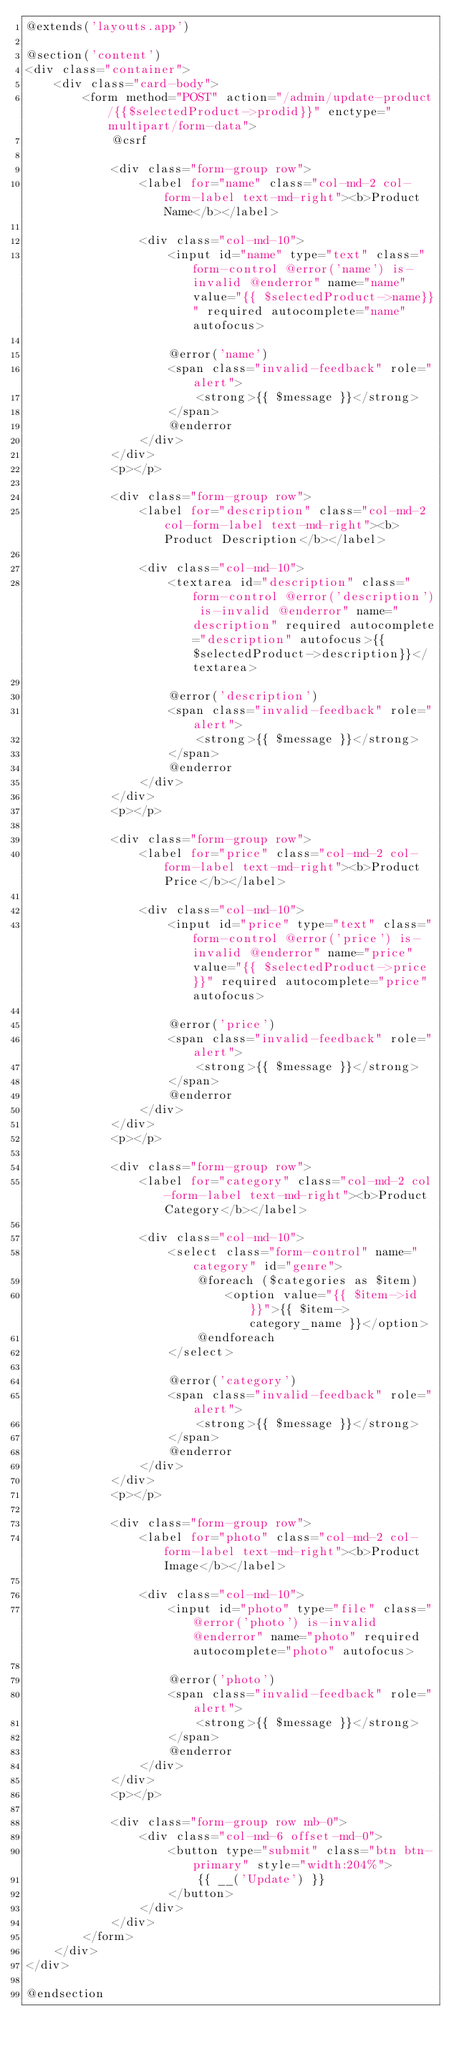Convert code to text. <code><loc_0><loc_0><loc_500><loc_500><_PHP_>@extends('layouts.app')

@section('content')
<div class="container">
    <div class="card-body">
        <form method="POST" action="/admin/update-product/{{$selectedProduct->prodid}}" enctype="multipart/form-data">
            @csrf

            <div class="form-group row">
                <label for="name" class="col-md-2 col-form-label text-md-right"><b>Product Name</b></label>

                <div class="col-md-10">
                    <input id="name" type="text" class="form-control @error('name') is-invalid @enderror" name="name" value="{{ $selectedProduct->name}}" required autocomplete="name" autofocus>

                    @error('name')
                    <span class="invalid-feedback" role="alert">
                        <strong>{{ $message }}</strong>
                    </span>
                    @enderror
                </div>
            </div>
            <p></p>

            <div class="form-group row">
                <label for="description" class="col-md-2 col-form-label text-md-right"><b>Product Description</b></label>

                <div class="col-md-10">
                    <textarea id="description" class="form-control @error('description') is-invalid @enderror" name="description" required autocomplete="description" autofocus>{{ $selectedProduct->description}}</textarea>

                    @error('description')
                    <span class="invalid-feedback" role="alert">
                        <strong>{{ $message }}</strong>
                    </span>
                    @enderror
                </div>
            </div>
            <p></p>

            <div class="form-group row">
                <label for="price" class="col-md-2 col-form-label text-md-right"><b>Product Price</b></label>

                <div class="col-md-10">
                    <input id="price" type="text" class="form-control @error('price') is-invalid @enderror" name="price" value="{{ $selectedProduct->price}}" required autocomplete="price" autofocus>

                    @error('price')
                    <span class="invalid-feedback" role="alert">
                        <strong>{{ $message }}</strong>
                    </span>
                    @enderror
                </div>
            </div>
            <p></p>

            <div class="form-group row">
                <label for="category" class="col-md-2 col-form-label text-md-right"><b>Product Category</b></label>

                <div class="col-md-10">
                    <select class="form-control" name="category" id="genre">
                        @foreach ($categories as $item)
                            <option value="{{ $item->id }}">{{ $item->category_name }}</option>
                        @endforeach
                    </select>

                    @error('category')
                    <span class="invalid-feedback" role="alert">
                        <strong>{{ $message }}</strong>
                    </span>
                    @enderror
                </div>
            </div>
            <p></p>

            <div class="form-group row">
                <label for="photo" class="col-md-2 col-form-label text-md-right"><b>Product Image</b></label>

                <div class="col-md-10">
                    <input id="photo" type="file" class="@error('photo') is-invalid @enderror" name="photo" required autocomplete="photo" autofocus>

                    @error('photo')
                    <span class="invalid-feedback" role="alert">
                        <strong>{{ $message }}</strong>
                    </span>
                    @enderror
                </div>
            </div>
            <p></p>

            <div class="form-group row mb-0">
                <div class="col-md-6 offset-md-0">
                    <button type="submit" class="btn btn-primary" style="width:204%">
                        {{ __('Update') }}
                    </button>
                </div>
            </div>
        </form>
    </div>
</div>

@endsection</code> 